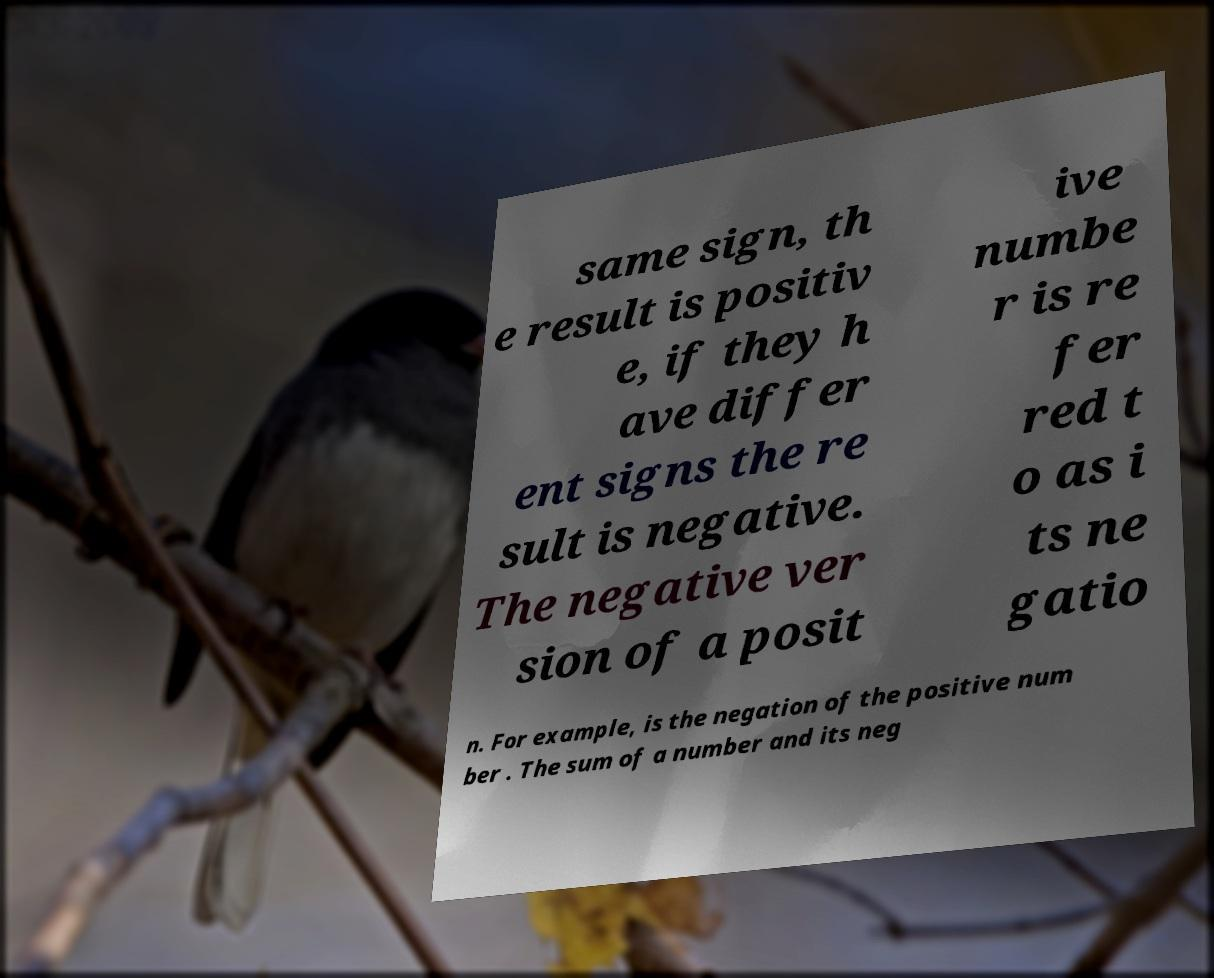There's text embedded in this image that I need extracted. Can you transcribe it verbatim? same sign, th e result is positiv e, if they h ave differ ent signs the re sult is negative. The negative ver sion of a posit ive numbe r is re fer red t o as i ts ne gatio n. For example, is the negation of the positive num ber . The sum of a number and its neg 